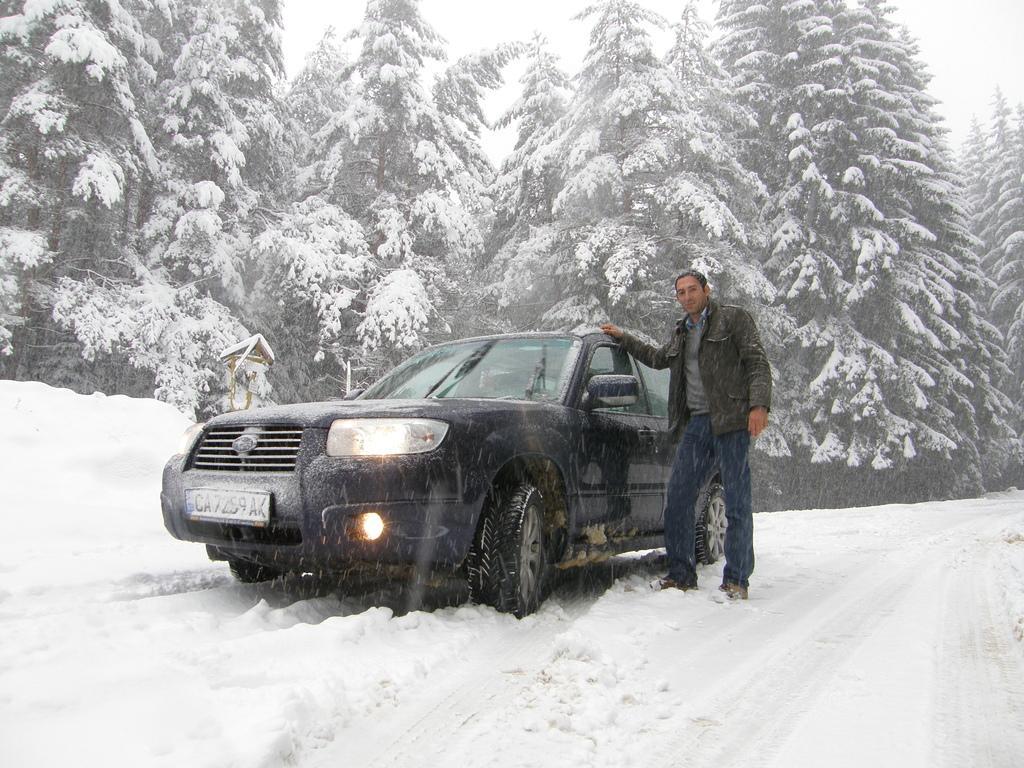In one or two sentences, can you explain what this image depicts? In this image we can see a vehicle, a person and other objects. In the background of the image there are some trees covered with snow and the sky. At the bottom of the image there is the snow. 